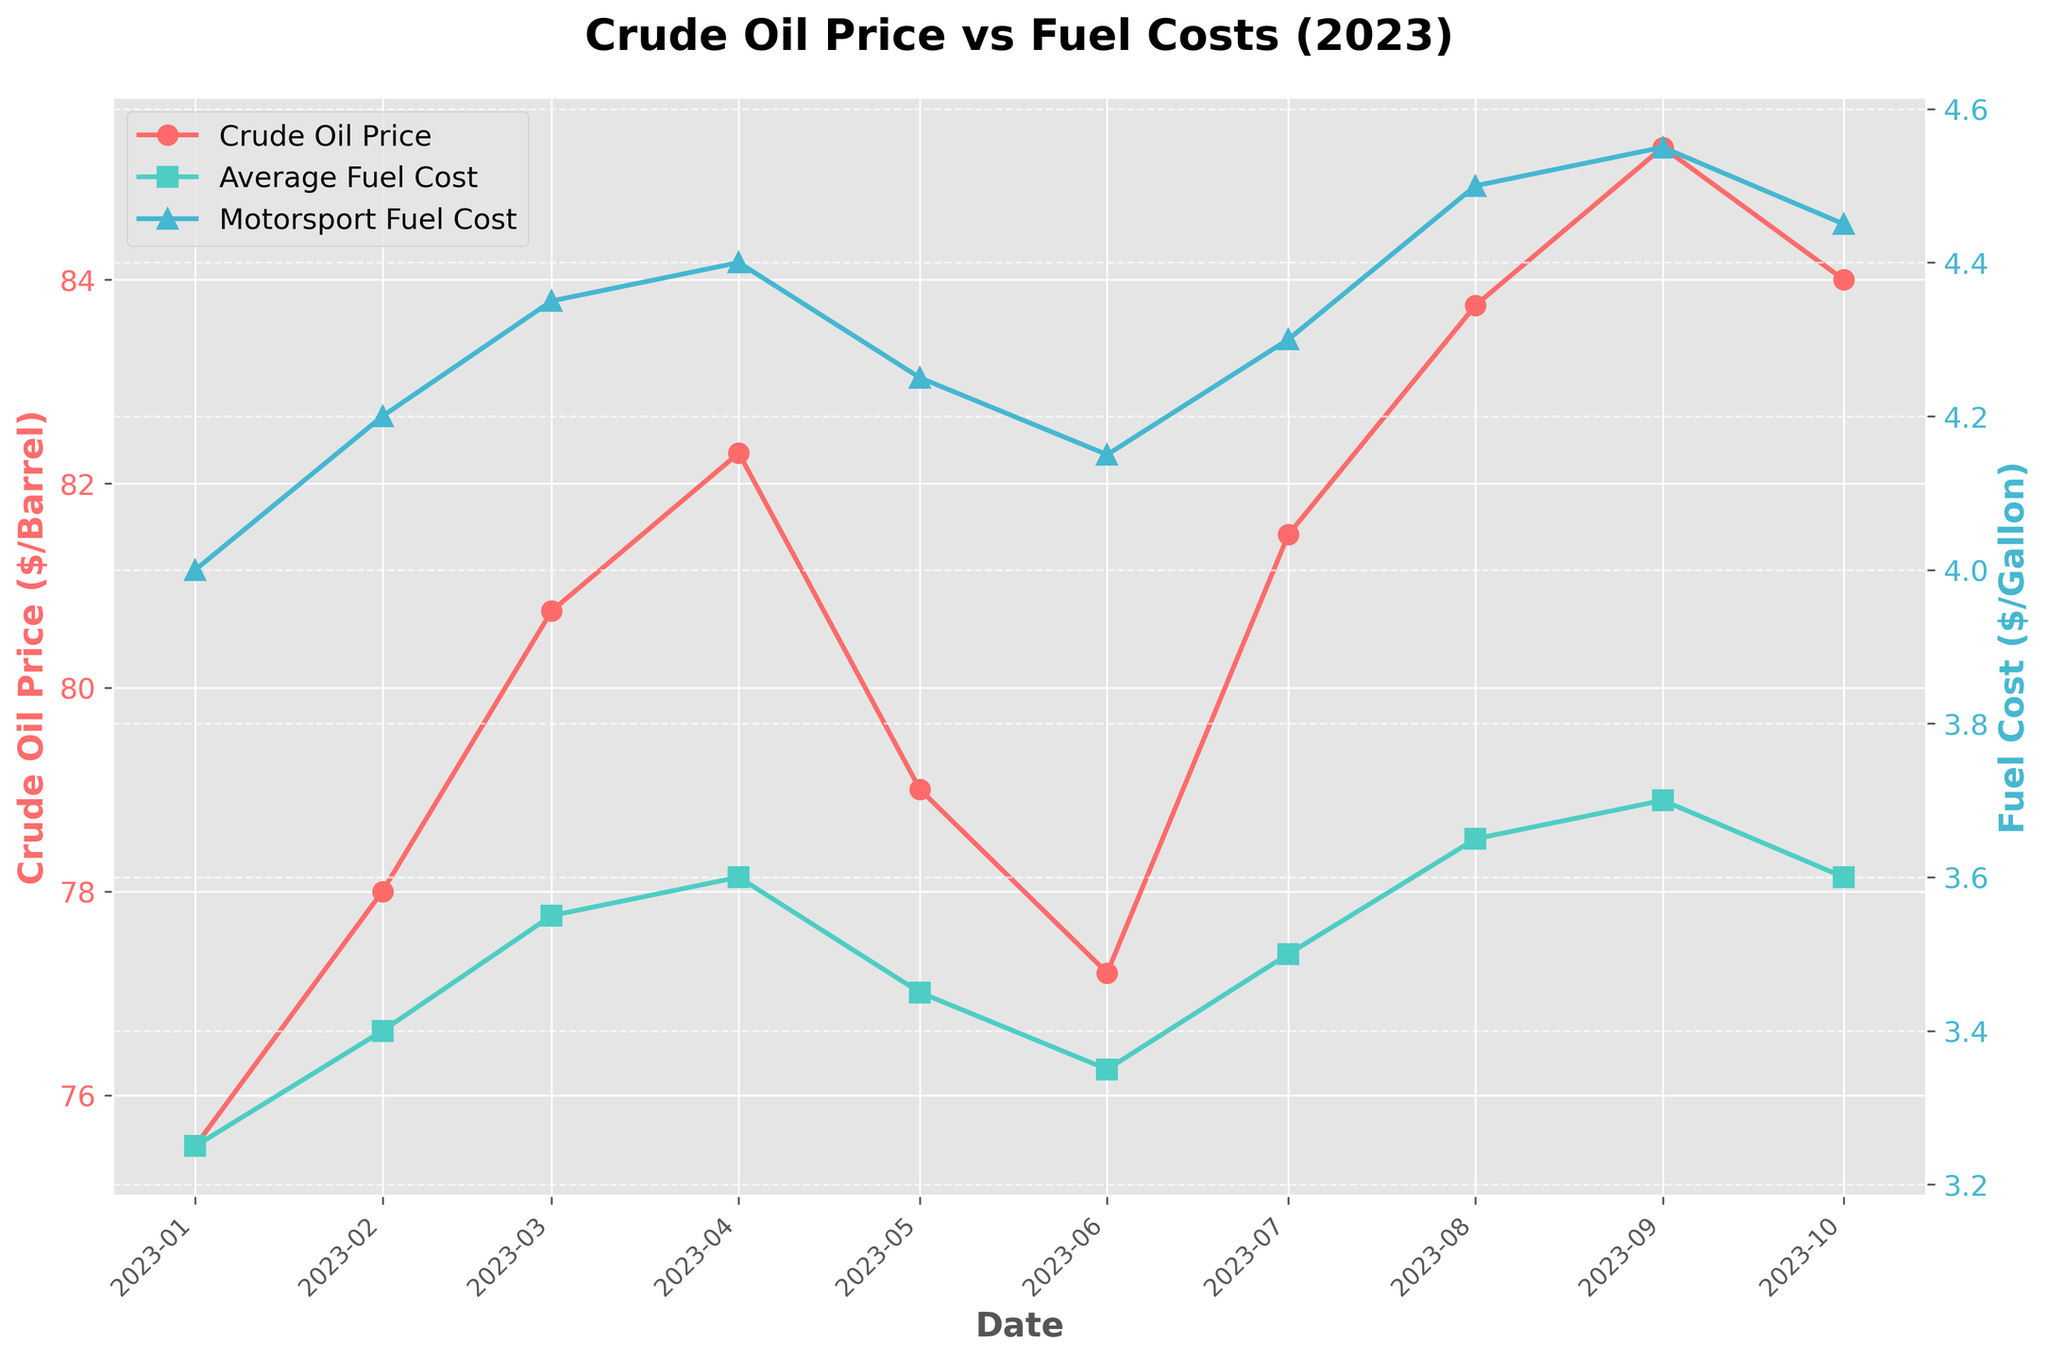What is the title of the plot? The title of the plot is usually situated at the top of the figure. By looking at the figure, you would see the text describing the chart's subject.
Answer: Crude Oil Price vs Fuel Costs (2023) What are the units used for the Crude Oil Price and Fuel Cost? The units for Crude Oil Price are dollars per barrel, as mentioned on the left y-axis label. The units for Fuel Cost are dollars per gallon, which is on the right y-axis label.
Answer: Dollars per barrel and dollars per gallon What trend do you observe in the Crude Oil Price over the period from January to October 2023? The Crude Oil Price generally increases from January to April, then dips in May and June, rises again till it peaks in September, and decreases slightly in October.
Answer: Rising, dipping, peaking, then slight decrease How did the Motorsport Fuel Cost per Gallon change from January to October 2023? To answer this, look at the series for Motorsport Fuel Cost per Gallon, which is in blue with triangle markers. Start at January and follow the points month by month up until October. It overall shows an increasing trend.
Answer: Increasing trend Which month had the highest Crude Oil Price per Barrel and what was the price? Locate the highest point on the red line representing the Crude Oil Price and read the corresponding month and price on the x-axis and y-axis respectively.
Answer: September, $85.30 Compare the Average Fuel Cost per Gallon and Motorsport Fuel Cost per Gallon for April 2023. Which one is higher and by how much? Locate the data points for April on the green and blue lines. The Motorsport Fuel Cost is higher. Subtract the Average Fuel Cost from the Motorsport Fuel Cost to find the difference.
Answer: Motorsport Fuel Cost is higher by $0.80 What is the largest difference between Motorsport Fuel Cost per Gallon and Average Fuel Cost per Gallon in 2023? Determine by finding the maximum difference between the blue and green points for each month and identifying the largest value.
Answer: $0.90 in September If the trend from September to October continued, what might we predict about Crude Oil Price for November? The Crude Oil Price showed a slight decrease from September to October. If this trend continued, we might predict another slight decrease or stabilization in November.
Answer: Slight decrease or stabilization How does the variability in Crude Oil Prices seem to affect Motorsport Fuel Costs compared to Average Fuel Costs? Observe fluctuations in Crude Oil Prices and look at how both the Average Fuel Cost and Motorsport Fuel Cost respond. Generally, both fuel costs rise and fall following the Crude Oil Price changes, but Motorsport Fuel Cost tends to be higher and follow fluctuations more closely.
Answer: Motorsport Fuel Costs follow more closely What correlation can you infer between Crude Oil Price per Barrel and Motorsport Fuel Cost per Gallon over 2023? Analyze the visual correlation between the red line (Crude Oil Price) and the blue line (Motorsport Fuel Cost). They track similarly, implying a positive correlation. When the Crude Oil Price increases, Motorsport Fuel Cost also tends to increase.
Answer: Positive correlation 